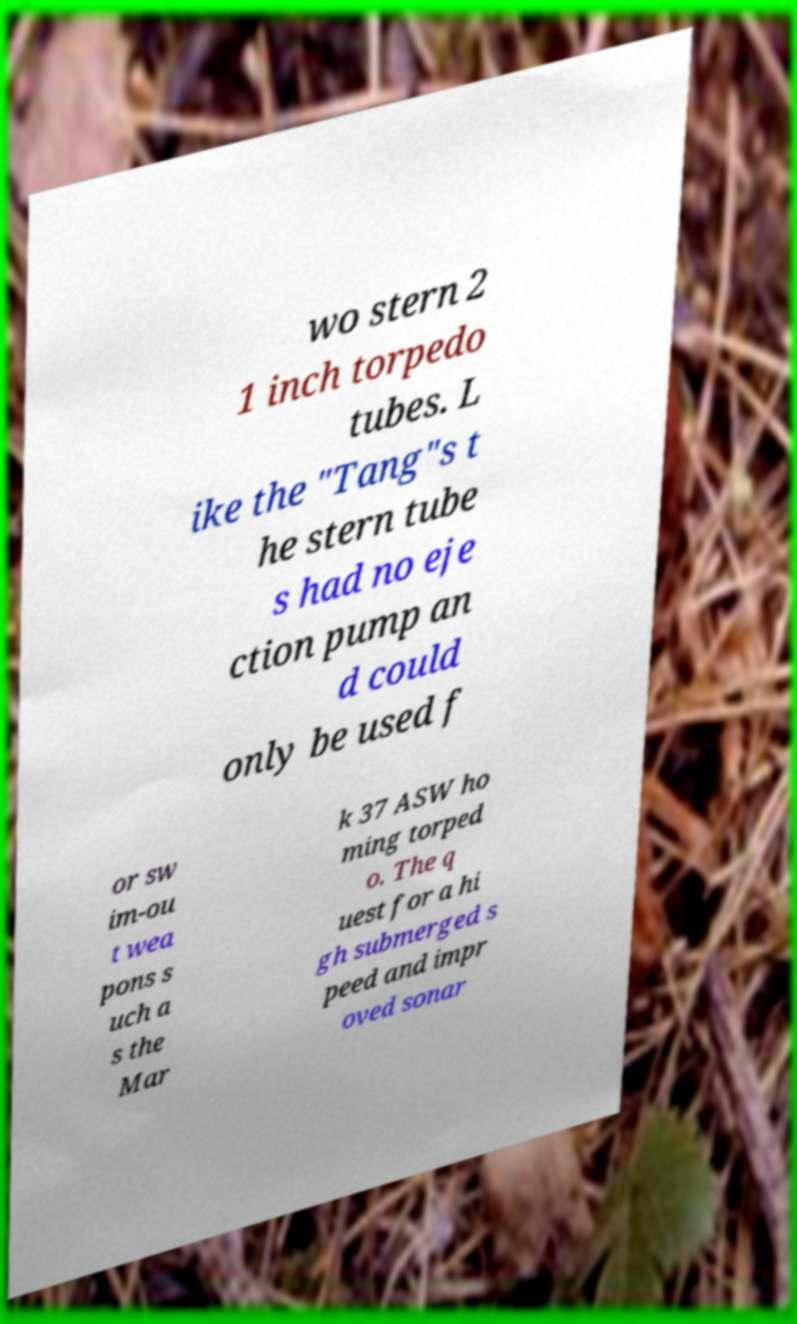Can you read and provide the text displayed in the image?This photo seems to have some interesting text. Can you extract and type it out for me? wo stern 2 1 inch torpedo tubes. L ike the "Tang"s t he stern tube s had no eje ction pump an d could only be used f or sw im-ou t wea pons s uch a s the Mar k 37 ASW ho ming torped o. The q uest for a hi gh submerged s peed and impr oved sonar 